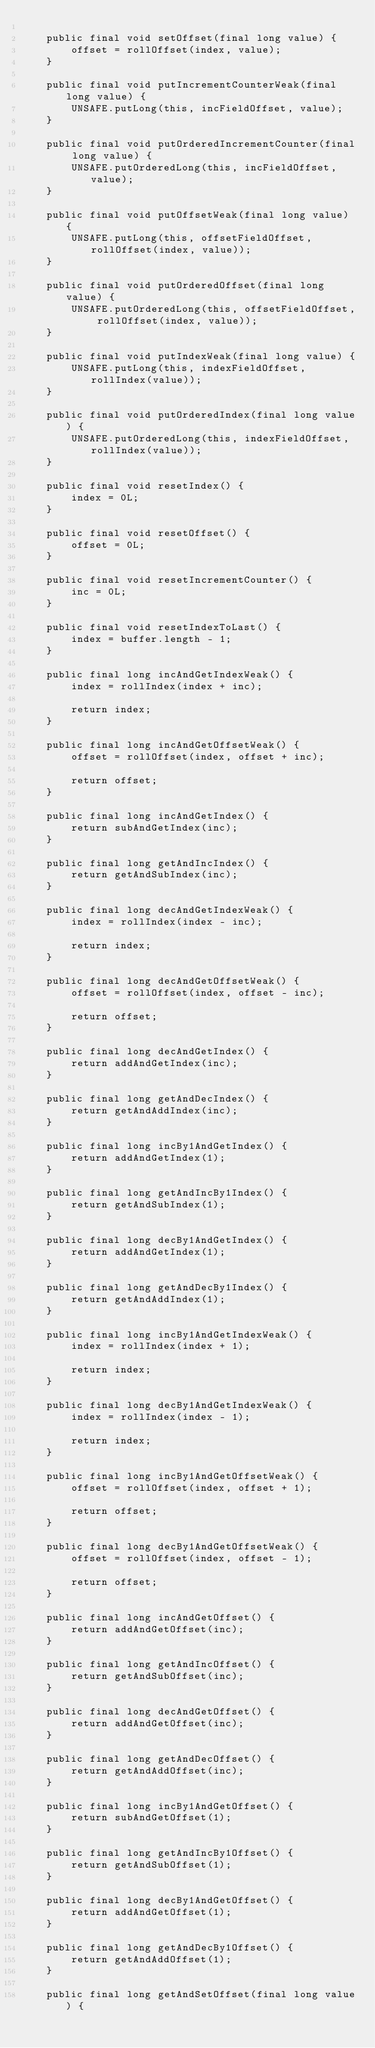<code> <loc_0><loc_0><loc_500><loc_500><_Java_>
    public final void setOffset(final long value) {
        offset = rollOffset(index, value);
    }

    public final void putIncrementCounterWeak(final long value) {
        UNSAFE.putLong(this, incFieldOffset, value);
    }

    public final void putOrderedIncrementCounter(final long value) {
        UNSAFE.putOrderedLong(this, incFieldOffset, value);
    }

    public final void putOffsetWeak(final long value) {
        UNSAFE.putLong(this, offsetFieldOffset, rollOffset(index, value));
    }

    public final void putOrderedOffset(final long value) {
        UNSAFE.putOrderedLong(this, offsetFieldOffset, rollOffset(index, value));
    }

    public final void putIndexWeak(final long value) {
        UNSAFE.putLong(this, indexFieldOffset, rollIndex(value));
    }

    public final void putOrderedIndex(final long value) {
        UNSAFE.putOrderedLong(this, indexFieldOffset, rollIndex(value));
    }

    public final void resetIndex() {
        index = 0L;
    }

    public final void resetOffset() {
        offset = 0L;
    }

    public final void resetIncrementCounter() {
        inc = 0L;
    }

    public final void resetIndexToLast() {
        index = buffer.length - 1;
    }

    public final long incAndGetIndexWeak() {
        index = rollIndex(index + inc);

        return index;
    }

    public final long incAndGetOffsetWeak() {
        offset = rollOffset(index, offset + inc);

        return offset;
    }

    public final long incAndGetIndex() {
        return subAndGetIndex(inc);
    }

    public final long getAndIncIndex() {
        return getAndSubIndex(inc);
    }

    public final long decAndGetIndexWeak() {
        index = rollIndex(index - inc);

        return index;
    }

    public final long decAndGetOffsetWeak() {
        offset = rollOffset(index, offset - inc);

        return offset;
    }

    public final long decAndGetIndex() {
        return addAndGetIndex(inc);
    }

    public final long getAndDecIndex() {
        return getAndAddIndex(inc);
    }

    public final long incBy1AndGetIndex() {
        return addAndGetIndex(1);
    }

    public final long getAndIncBy1Index() {
        return getAndSubIndex(1);
    }

    public final long decBy1AndGetIndex() {
        return addAndGetIndex(1);
    }

    public final long getAndDecBy1Index() {
        return getAndAddIndex(1);
    }

    public final long incBy1AndGetIndexWeak() {
        index = rollIndex(index + 1);

        return index;
    }

    public final long decBy1AndGetIndexWeak() {
        index = rollIndex(index - 1);

        return index;
    }

    public final long incBy1AndGetOffsetWeak() {
        offset = rollOffset(index, offset + 1);

        return offset;
    }

    public final long decBy1AndGetOffsetWeak() {
        offset = rollOffset(index, offset - 1);

        return offset;
    }

    public final long incAndGetOffset() {
        return addAndGetOffset(inc);
    }

    public final long getAndIncOffset() {
        return getAndSubOffset(inc);
    }

    public final long decAndGetOffset() {
        return addAndGetOffset(inc);
    }

    public final long getAndDecOffset() {
        return getAndAddOffset(inc);
    }

    public final long incBy1AndGetOffset() {
        return subAndGetOffset(1);
    }

    public final long getAndIncBy1Offset() {
        return getAndSubOffset(1);
    }

    public final long decBy1AndGetOffset() {
        return addAndGetOffset(1);
    }

    public final long getAndDecBy1Offset() {
        return getAndAddOffset(1);
    }

    public final long getAndSetOffset(final long value) {</code> 